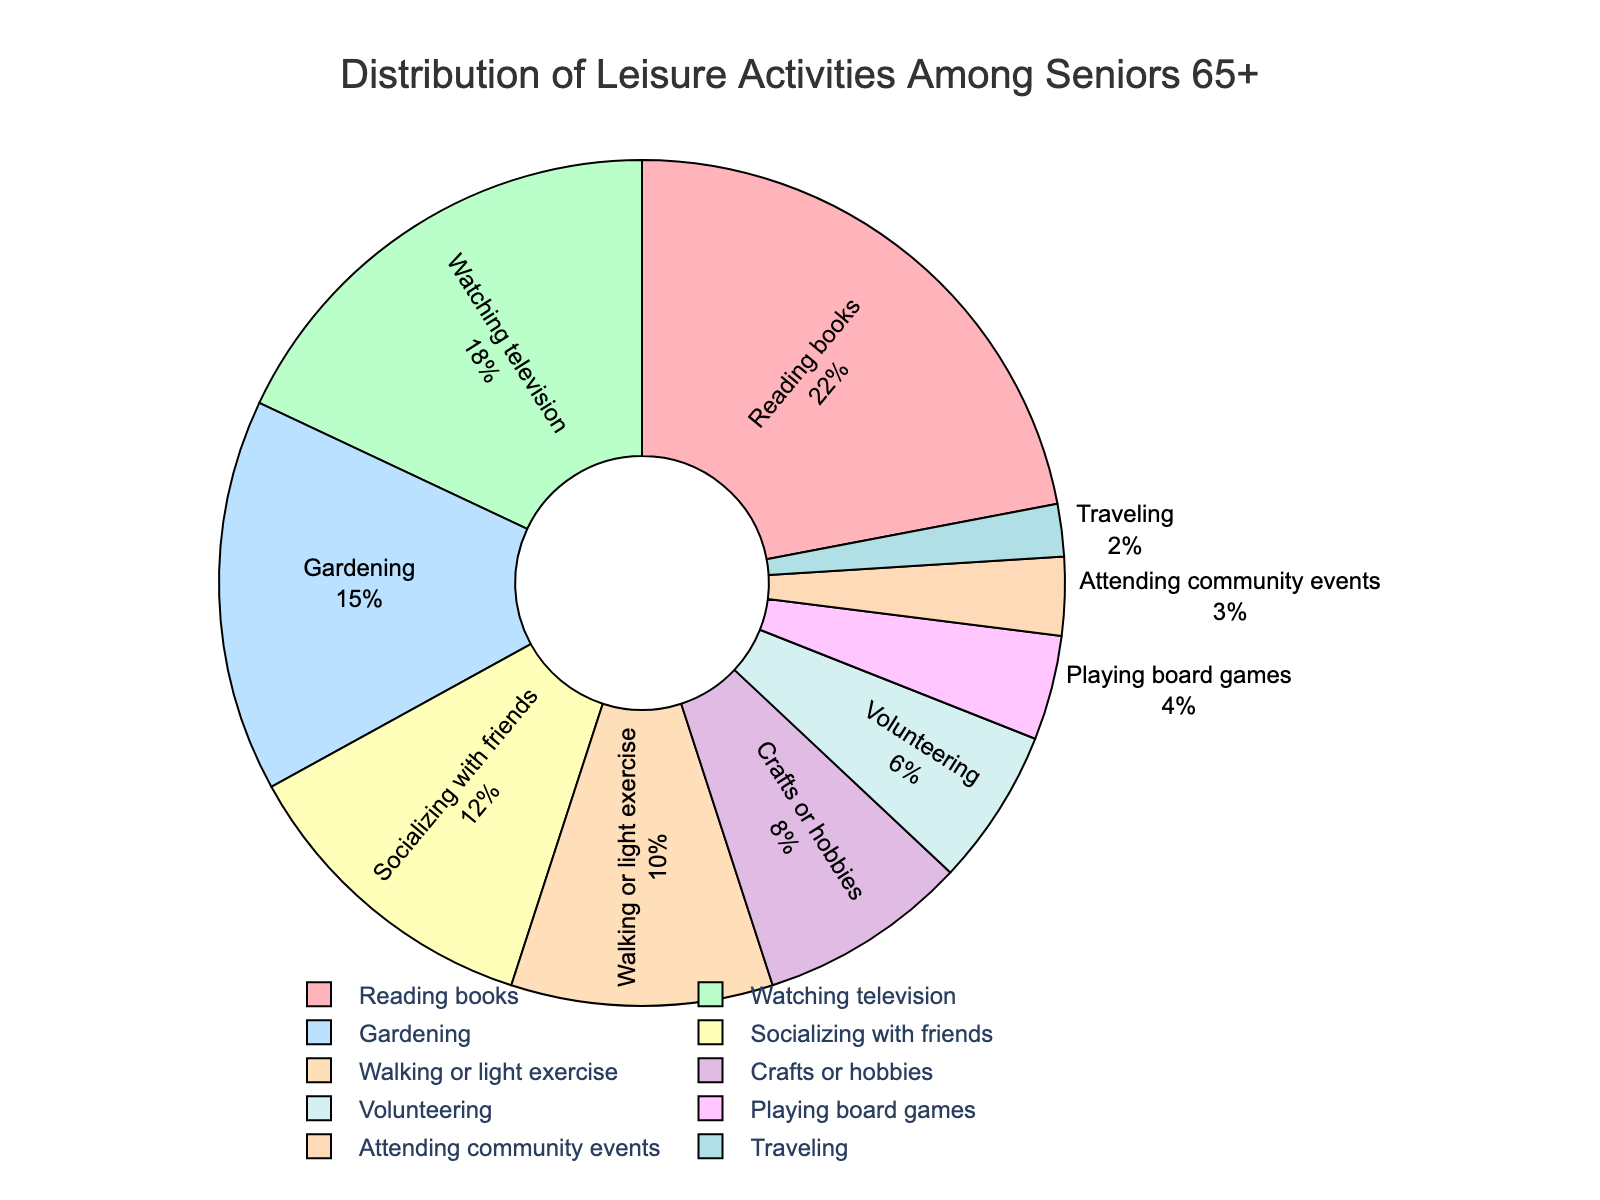which activity has the highest percentage? The slice representing "Reading books" has the largest area in the pie chart, taking up 22% of the distribution. "Reading books" is labeled along with its percentage value.
Answer: "Reading books" what is the combined percentage of gardening and socializing with friends? The pie chart shows that "Gardening" is 15% and "Socializing with friends" is 12%. Adding these two percentages together: 15 + 12 = 27%
Answer: 27% which activity has a larger percentage, walking or light exercise, or crafts or hobbies? The pie chart indicates "Walking or light exercise" at 10% and "Crafts or hobbies" at 8%. 10% is greater than 8%.
Answer: "Walking or light exercise" what's the difference in percentage between watching television and traveling? "Watching television" represents 18% of the pie chart, while "Traveling" is 2%. Subtracting these: 18 - 2 = 16%
Answer: 16% how many activities make up at least 10% of the leisure activities? The pie chart shows "Reading books" (22%), "Watching television" (18%), "Gardening" (15%), "Socializing with friends" (12%), and "Walking or light exercise" (10%). That's 5 activities.
Answer: 5 which activity is represented by the purple slice in the pie chart? The key for colors in the pie chart indicates the purple slice represents "Crafts or hobbies."
Answer: "Crafts or hobbies" compare the percentages of volunteering and playing board games. Which one is higher? In the pie chart, "Volunteering" is 6% and "Playing board games" is 4%. 6% is higher than 4%.
Answer: "Volunteering" calculate the total percentage of activities that are below 5%. The pie chart shows "Playing board games" at 4% and "Attending community events" at 3%, and "Traveling" at 2%. Adding these: 4 + 3 + 2 = 9%
Answer: 9% which activity accounts for the smallest percentage of leisure activities? The pie chart indicates that "Traveling" has the smallest area with 2%.
Answer: "Traveling" is the percentage of socializing with friends greater than that of volunteering, playing board games, and attending community events combined? The pie chart shows "Socializing with friends" as 12%. "Volunteering" is 6%, "Playing board games" is 4%, and "Attending community events" is 3%. Adding these: 6 + 4 + 3 = 13%. 12% is less than 13%.
Answer: no 